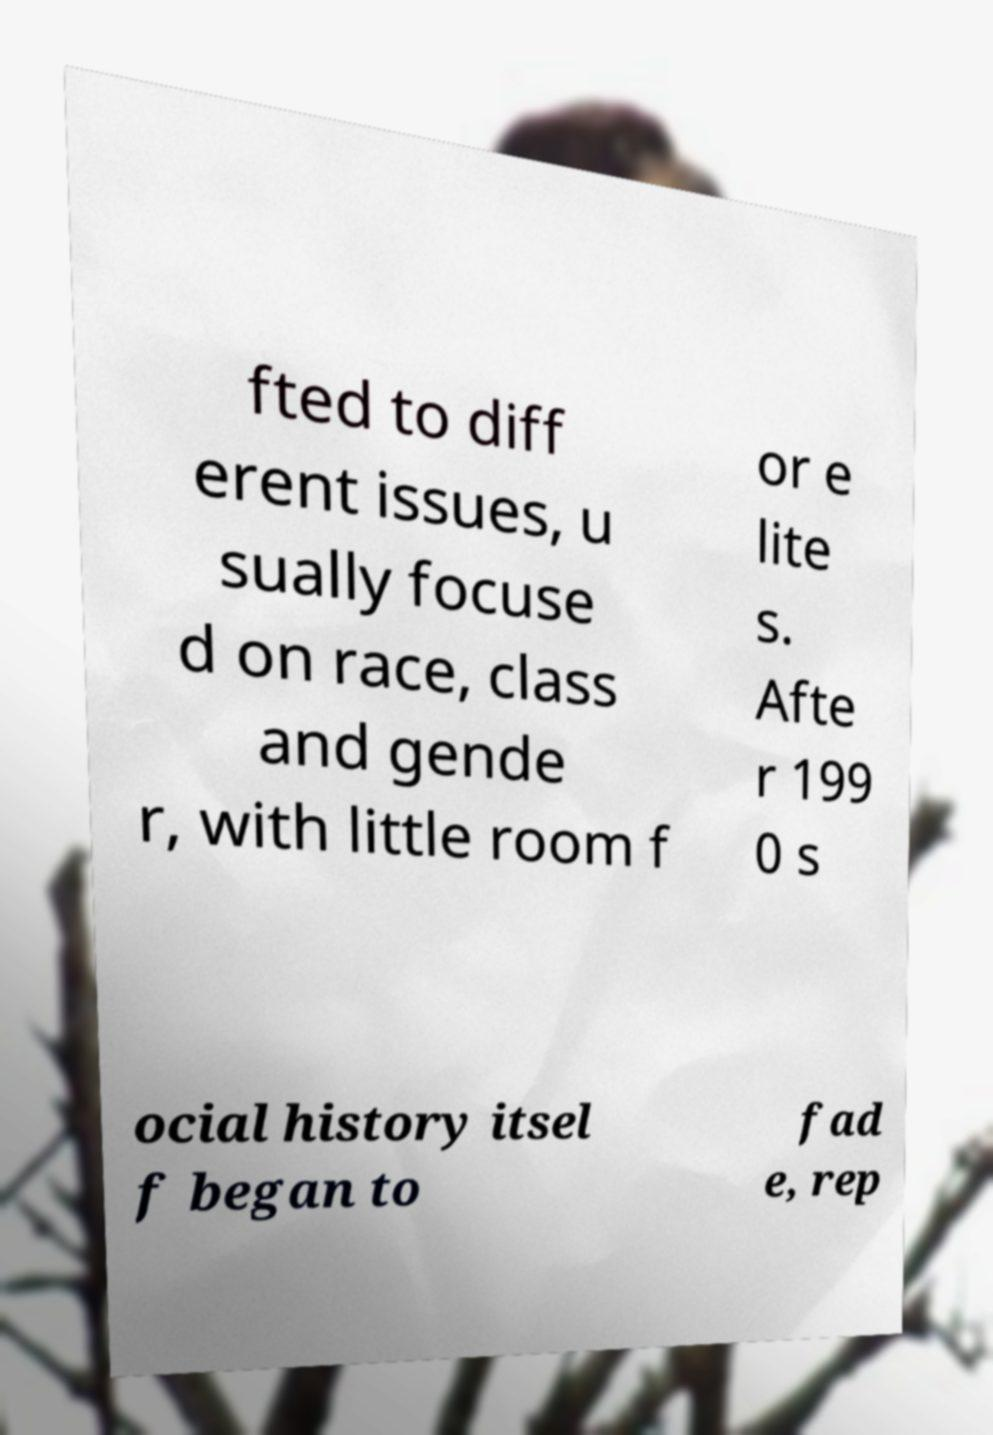Could you extract and type out the text from this image? fted to diff erent issues, u sually focuse d on race, class and gende r, with little room f or e lite s. Afte r 199 0 s ocial history itsel f began to fad e, rep 